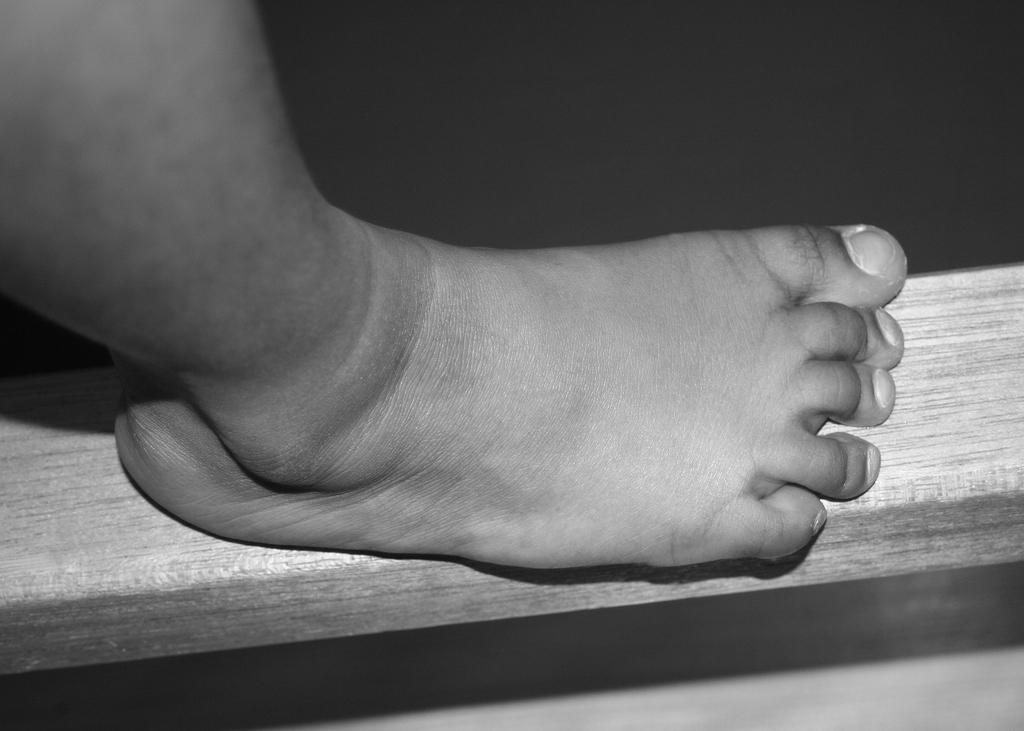What part of the human body is visible in the image? There is a human leg in the image. What is the color scheme of the image? The image is black and white. What can be said about the background of the image? The background of the image is dark. What type of stick is being used to play a musical instrument in the image? There is no stick or musical instrument present in the image; it only features a human leg. How many fingers can be seen holding the vase in the image? There is no vase or fingers present in the image; it only features a human leg. 